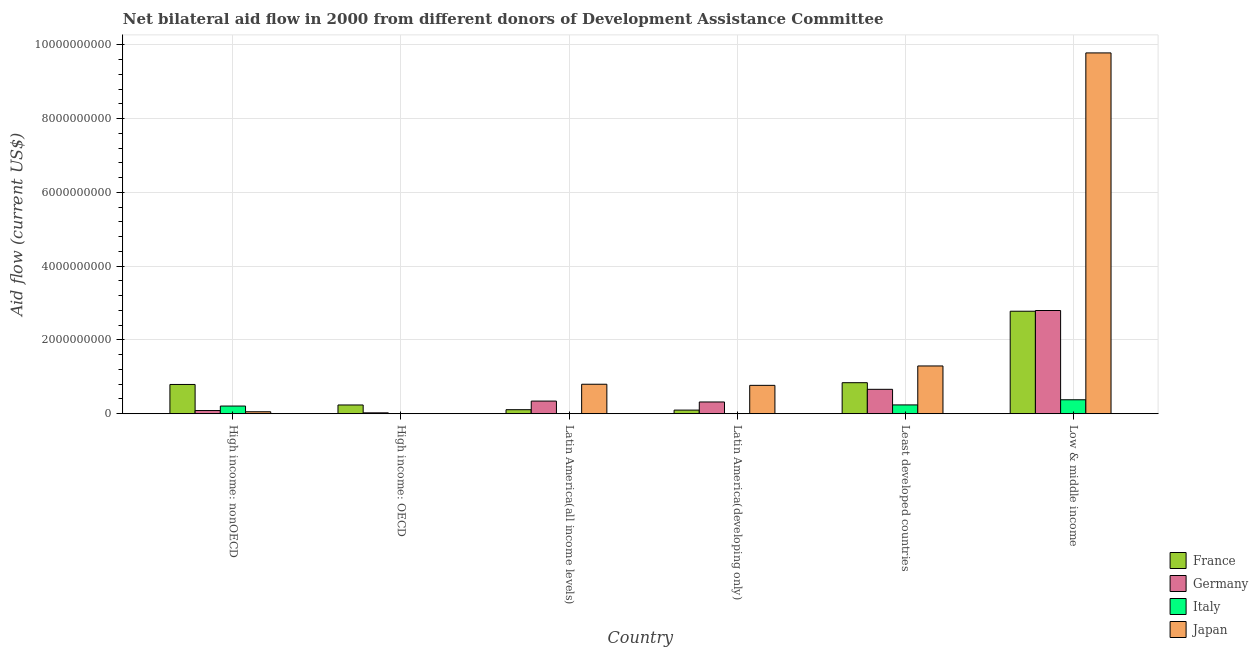How many groups of bars are there?
Your response must be concise. 6. How many bars are there on the 1st tick from the left?
Make the answer very short. 4. What is the label of the 1st group of bars from the left?
Make the answer very short. High income: nonOECD. What is the amount of aid given by france in Latin America(developing only)?
Your answer should be very brief. 9.84e+07. Across all countries, what is the maximum amount of aid given by italy?
Ensure brevity in your answer.  3.79e+08. What is the total amount of aid given by italy in the graph?
Give a very brief answer. 8.29e+08. What is the difference between the amount of aid given by france in High income: nonOECD and that in Least developed countries?
Offer a very short reply. -4.81e+07. What is the difference between the amount of aid given by japan in Latin America(all income levels) and the amount of aid given by italy in Low & middle income?
Your response must be concise. 4.21e+08. What is the average amount of aid given by germany per country?
Your response must be concise. 7.06e+08. What is the difference between the amount of aid given by japan and amount of aid given by france in High income: nonOECD?
Provide a short and direct response. -7.40e+08. In how many countries, is the amount of aid given by france greater than 6800000000 US$?
Offer a terse response. 0. What is the ratio of the amount of aid given by germany in High income: OECD to that in High income: nonOECD?
Provide a succinct answer. 0.28. Is the difference between the amount of aid given by italy in High income: nonOECD and Low & middle income greater than the difference between the amount of aid given by france in High income: nonOECD and Low & middle income?
Give a very brief answer. Yes. What is the difference between the highest and the second highest amount of aid given by germany?
Ensure brevity in your answer.  2.14e+09. What is the difference between the highest and the lowest amount of aid given by japan?
Your answer should be very brief. 9.78e+09. In how many countries, is the amount of aid given by france greater than the average amount of aid given by france taken over all countries?
Provide a short and direct response. 2. Is it the case that in every country, the sum of the amount of aid given by japan and amount of aid given by germany is greater than the sum of amount of aid given by italy and amount of aid given by france?
Give a very brief answer. No. Is it the case that in every country, the sum of the amount of aid given by france and amount of aid given by germany is greater than the amount of aid given by italy?
Ensure brevity in your answer.  Yes. How many bars are there?
Provide a short and direct response. 21. Are all the bars in the graph horizontal?
Offer a very short reply. No. What is the difference between two consecutive major ticks on the Y-axis?
Your response must be concise. 2.00e+09. Does the graph contain any zero values?
Provide a short and direct response. Yes. How are the legend labels stacked?
Offer a very short reply. Vertical. What is the title of the graph?
Your answer should be compact. Net bilateral aid flow in 2000 from different donors of Development Assistance Committee. What is the label or title of the X-axis?
Your response must be concise. Country. What is the Aid flow (current US$) of France in High income: nonOECD?
Make the answer very short. 7.94e+08. What is the Aid flow (current US$) of Germany in High income: nonOECD?
Your answer should be compact. 8.66e+07. What is the Aid flow (current US$) of Italy in High income: nonOECD?
Offer a terse response. 2.08e+08. What is the Aid flow (current US$) of Japan in High income: nonOECD?
Give a very brief answer. 5.39e+07. What is the Aid flow (current US$) in France in High income: OECD?
Your answer should be very brief. 2.37e+08. What is the Aid flow (current US$) of Germany in High income: OECD?
Make the answer very short. 2.45e+07. What is the Aid flow (current US$) in Italy in High income: OECD?
Keep it short and to the point. 2.94e+06. What is the Aid flow (current US$) of France in Latin America(all income levels)?
Your response must be concise. 1.09e+08. What is the Aid flow (current US$) of Germany in Latin America(all income levels)?
Make the answer very short. 3.43e+08. What is the Aid flow (current US$) in Italy in Latin America(all income levels)?
Offer a very short reply. 0. What is the Aid flow (current US$) of Japan in Latin America(all income levels)?
Give a very brief answer. 8.00e+08. What is the Aid flow (current US$) of France in Latin America(developing only)?
Your answer should be compact. 9.84e+07. What is the Aid flow (current US$) of Germany in Latin America(developing only)?
Your response must be concise. 3.19e+08. What is the Aid flow (current US$) in Italy in Latin America(developing only)?
Offer a terse response. 0. What is the Aid flow (current US$) in Japan in Latin America(developing only)?
Provide a succinct answer. 7.69e+08. What is the Aid flow (current US$) of France in Least developed countries?
Your response must be concise. 8.42e+08. What is the Aid flow (current US$) in Germany in Least developed countries?
Your response must be concise. 6.62e+08. What is the Aid flow (current US$) in Italy in Least developed countries?
Give a very brief answer. 2.39e+08. What is the Aid flow (current US$) in Japan in Least developed countries?
Your answer should be compact. 1.30e+09. What is the Aid flow (current US$) of France in Low & middle income?
Give a very brief answer. 2.78e+09. What is the Aid flow (current US$) of Germany in Low & middle income?
Offer a terse response. 2.80e+09. What is the Aid flow (current US$) in Italy in Low & middle income?
Ensure brevity in your answer.  3.79e+08. What is the Aid flow (current US$) in Japan in Low & middle income?
Provide a short and direct response. 9.78e+09. Across all countries, what is the maximum Aid flow (current US$) in France?
Ensure brevity in your answer.  2.78e+09. Across all countries, what is the maximum Aid flow (current US$) in Germany?
Ensure brevity in your answer.  2.80e+09. Across all countries, what is the maximum Aid flow (current US$) in Italy?
Your answer should be very brief. 3.79e+08. Across all countries, what is the maximum Aid flow (current US$) of Japan?
Offer a terse response. 9.78e+09. Across all countries, what is the minimum Aid flow (current US$) in France?
Make the answer very short. 9.84e+07. Across all countries, what is the minimum Aid flow (current US$) in Germany?
Ensure brevity in your answer.  2.45e+07. Across all countries, what is the minimum Aid flow (current US$) of Italy?
Keep it short and to the point. 0. Across all countries, what is the minimum Aid flow (current US$) of Japan?
Offer a terse response. 0. What is the total Aid flow (current US$) in France in the graph?
Your response must be concise. 4.86e+09. What is the total Aid flow (current US$) of Germany in the graph?
Give a very brief answer. 4.23e+09. What is the total Aid flow (current US$) of Italy in the graph?
Your response must be concise. 8.29e+08. What is the total Aid flow (current US$) of Japan in the graph?
Provide a succinct answer. 1.27e+1. What is the difference between the Aid flow (current US$) in France in High income: nonOECD and that in High income: OECD?
Provide a short and direct response. 5.56e+08. What is the difference between the Aid flow (current US$) of Germany in High income: nonOECD and that in High income: OECD?
Offer a terse response. 6.21e+07. What is the difference between the Aid flow (current US$) of Italy in High income: nonOECD and that in High income: OECD?
Offer a very short reply. 2.05e+08. What is the difference between the Aid flow (current US$) in France in High income: nonOECD and that in Latin America(all income levels)?
Provide a succinct answer. 6.84e+08. What is the difference between the Aid flow (current US$) in Germany in High income: nonOECD and that in Latin America(all income levels)?
Your answer should be compact. -2.56e+08. What is the difference between the Aid flow (current US$) in Japan in High income: nonOECD and that in Latin America(all income levels)?
Provide a short and direct response. -7.46e+08. What is the difference between the Aid flow (current US$) in France in High income: nonOECD and that in Latin America(developing only)?
Ensure brevity in your answer.  6.95e+08. What is the difference between the Aid flow (current US$) in Germany in High income: nonOECD and that in Latin America(developing only)?
Offer a very short reply. -2.32e+08. What is the difference between the Aid flow (current US$) of Japan in High income: nonOECD and that in Latin America(developing only)?
Your response must be concise. -7.16e+08. What is the difference between the Aid flow (current US$) of France in High income: nonOECD and that in Least developed countries?
Your response must be concise. -4.81e+07. What is the difference between the Aid flow (current US$) in Germany in High income: nonOECD and that in Least developed countries?
Make the answer very short. -5.75e+08. What is the difference between the Aid flow (current US$) in Italy in High income: nonOECD and that in Least developed countries?
Provide a succinct answer. -3.09e+07. What is the difference between the Aid flow (current US$) of Japan in High income: nonOECD and that in Least developed countries?
Make the answer very short. -1.24e+09. What is the difference between the Aid flow (current US$) in France in High income: nonOECD and that in Low & middle income?
Your answer should be very brief. -1.99e+09. What is the difference between the Aid flow (current US$) in Germany in High income: nonOECD and that in Low & middle income?
Offer a terse response. -2.71e+09. What is the difference between the Aid flow (current US$) of Italy in High income: nonOECD and that in Low & middle income?
Keep it short and to the point. -1.70e+08. What is the difference between the Aid flow (current US$) in Japan in High income: nonOECD and that in Low & middle income?
Your response must be concise. -9.73e+09. What is the difference between the Aid flow (current US$) in France in High income: OECD and that in Latin America(all income levels)?
Your response must be concise. 1.28e+08. What is the difference between the Aid flow (current US$) in Germany in High income: OECD and that in Latin America(all income levels)?
Offer a very short reply. -3.18e+08. What is the difference between the Aid flow (current US$) in France in High income: OECD and that in Latin America(developing only)?
Your answer should be very brief. 1.39e+08. What is the difference between the Aid flow (current US$) in Germany in High income: OECD and that in Latin America(developing only)?
Ensure brevity in your answer.  -2.94e+08. What is the difference between the Aid flow (current US$) in France in High income: OECD and that in Least developed countries?
Give a very brief answer. -6.04e+08. What is the difference between the Aid flow (current US$) in Germany in High income: OECD and that in Least developed countries?
Make the answer very short. -6.37e+08. What is the difference between the Aid flow (current US$) of Italy in High income: OECD and that in Least developed countries?
Keep it short and to the point. -2.36e+08. What is the difference between the Aid flow (current US$) in France in High income: OECD and that in Low & middle income?
Ensure brevity in your answer.  -2.54e+09. What is the difference between the Aid flow (current US$) of Germany in High income: OECD and that in Low & middle income?
Offer a terse response. -2.77e+09. What is the difference between the Aid flow (current US$) of Italy in High income: OECD and that in Low & middle income?
Provide a short and direct response. -3.76e+08. What is the difference between the Aid flow (current US$) in France in Latin America(all income levels) and that in Latin America(developing only)?
Offer a very short reply. 1.10e+07. What is the difference between the Aid flow (current US$) in Germany in Latin America(all income levels) and that in Latin America(developing only)?
Make the answer very short. 2.43e+07. What is the difference between the Aid flow (current US$) in Japan in Latin America(all income levels) and that in Latin America(developing only)?
Ensure brevity in your answer.  3.01e+07. What is the difference between the Aid flow (current US$) in France in Latin America(all income levels) and that in Least developed countries?
Provide a short and direct response. -7.32e+08. What is the difference between the Aid flow (current US$) in Germany in Latin America(all income levels) and that in Least developed countries?
Make the answer very short. -3.19e+08. What is the difference between the Aid flow (current US$) of Japan in Latin America(all income levels) and that in Least developed countries?
Your response must be concise. -4.96e+08. What is the difference between the Aid flow (current US$) of France in Latin America(all income levels) and that in Low & middle income?
Your answer should be compact. -2.67e+09. What is the difference between the Aid flow (current US$) of Germany in Latin America(all income levels) and that in Low & middle income?
Provide a short and direct response. -2.46e+09. What is the difference between the Aid flow (current US$) in Japan in Latin America(all income levels) and that in Low & middle income?
Make the answer very short. -8.98e+09. What is the difference between the Aid flow (current US$) in France in Latin America(developing only) and that in Least developed countries?
Offer a very short reply. -7.43e+08. What is the difference between the Aid flow (current US$) of Germany in Latin America(developing only) and that in Least developed countries?
Your response must be concise. -3.43e+08. What is the difference between the Aid flow (current US$) in Japan in Latin America(developing only) and that in Least developed countries?
Ensure brevity in your answer.  -5.26e+08. What is the difference between the Aid flow (current US$) in France in Latin America(developing only) and that in Low & middle income?
Give a very brief answer. -2.68e+09. What is the difference between the Aid flow (current US$) of Germany in Latin America(developing only) and that in Low & middle income?
Give a very brief answer. -2.48e+09. What is the difference between the Aid flow (current US$) of Japan in Latin America(developing only) and that in Low & middle income?
Ensure brevity in your answer.  -9.01e+09. What is the difference between the Aid flow (current US$) of France in Least developed countries and that in Low & middle income?
Offer a terse response. -1.94e+09. What is the difference between the Aid flow (current US$) of Germany in Least developed countries and that in Low & middle income?
Provide a succinct answer. -2.14e+09. What is the difference between the Aid flow (current US$) of Italy in Least developed countries and that in Low & middle income?
Give a very brief answer. -1.39e+08. What is the difference between the Aid flow (current US$) in Japan in Least developed countries and that in Low & middle income?
Give a very brief answer. -8.49e+09. What is the difference between the Aid flow (current US$) in France in High income: nonOECD and the Aid flow (current US$) in Germany in High income: OECD?
Ensure brevity in your answer.  7.69e+08. What is the difference between the Aid flow (current US$) of France in High income: nonOECD and the Aid flow (current US$) of Italy in High income: OECD?
Offer a terse response. 7.91e+08. What is the difference between the Aid flow (current US$) of Germany in High income: nonOECD and the Aid flow (current US$) of Italy in High income: OECD?
Keep it short and to the point. 8.37e+07. What is the difference between the Aid flow (current US$) in France in High income: nonOECD and the Aid flow (current US$) in Germany in Latin America(all income levels)?
Provide a succinct answer. 4.51e+08. What is the difference between the Aid flow (current US$) in France in High income: nonOECD and the Aid flow (current US$) in Japan in Latin America(all income levels)?
Ensure brevity in your answer.  -6.02e+06. What is the difference between the Aid flow (current US$) of Germany in High income: nonOECD and the Aid flow (current US$) of Japan in Latin America(all income levels)?
Your response must be concise. -7.13e+08. What is the difference between the Aid flow (current US$) of Italy in High income: nonOECD and the Aid flow (current US$) of Japan in Latin America(all income levels)?
Provide a short and direct response. -5.91e+08. What is the difference between the Aid flow (current US$) of France in High income: nonOECD and the Aid flow (current US$) of Germany in Latin America(developing only)?
Your answer should be very brief. 4.75e+08. What is the difference between the Aid flow (current US$) in France in High income: nonOECD and the Aid flow (current US$) in Japan in Latin America(developing only)?
Your answer should be compact. 2.41e+07. What is the difference between the Aid flow (current US$) of Germany in High income: nonOECD and the Aid flow (current US$) of Japan in Latin America(developing only)?
Provide a short and direct response. -6.83e+08. What is the difference between the Aid flow (current US$) of Italy in High income: nonOECD and the Aid flow (current US$) of Japan in Latin America(developing only)?
Provide a succinct answer. -5.61e+08. What is the difference between the Aid flow (current US$) in France in High income: nonOECD and the Aid flow (current US$) in Germany in Least developed countries?
Keep it short and to the point. 1.32e+08. What is the difference between the Aid flow (current US$) in France in High income: nonOECD and the Aid flow (current US$) in Italy in Least developed countries?
Offer a very short reply. 5.54e+08. What is the difference between the Aid flow (current US$) in France in High income: nonOECD and the Aid flow (current US$) in Japan in Least developed countries?
Your answer should be very brief. -5.02e+08. What is the difference between the Aid flow (current US$) of Germany in High income: nonOECD and the Aid flow (current US$) of Italy in Least developed countries?
Offer a very short reply. -1.53e+08. What is the difference between the Aid flow (current US$) in Germany in High income: nonOECD and the Aid flow (current US$) in Japan in Least developed countries?
Offer a terse response. -1.21e+09. What is the difference between the Aid flow (current US$) of Italy in High income: nonOECD and the Aid flow (current US$) of Japan in Least developed countries?
Provide a short and direct response. -1.09e+09. What is the difference between the Aid flow (current US$) in France in High income: nonOECD and the Aid flow (current US$) in Germany in Low & middle income?
Make the answer very short. -2.00e+09. What is the difference between the Aid flow (current US$) in France in High income: nonOECD and the Aid flow (current US$) in Italy in Low & middle income?
Ensure brevity in your answer.  4.15e+08. What is the difference between the Aid flow (current US$) of France in High income: nonOECD and the Aid flow (current US$) of Japan in Low & middle income?
Provide a short and direct response. -8.99e+09. What is the difference between the Aid flow (current US$) of Germany in High income: nonOECD and the Aid flow (current US$) of Italy in Low & middle income?
Your answer should be very brief. -2.92e+08. What is the difference between the Aid flow (current US$) in Germany in High income: nonOECD and the Aid flow (current US$) in Japan in Low & middle income?
Provide a succinct answer. -9.69e+09. What is the difference between the Aid flow (current US$) of Italy in High income: nonOECD and the Aid flow (current US$) of Japan in Low & middle income?
Keep it short and to the point. -9.57e+09. What is the difference between the Aid flow (current US$) in France in High income: OECD and the Aid flow (current US$) in Germany in Latin America(all income levels)?
Offer a very short reply. -1.06e+08. What is the difference between the Aid flow (current US$) of France in High income: OECD and the Aid flow (current US$) of Japan in Latin America(all income levels)?
Provide a short and direct response. -5.62e+08. What is the difference between the Aid flow (current US$) of Germany in High income: OECD and the Aid flow (current US$) of Japan in Latin America(all income levels)?
Your response must be concise. -7.75e+08. What is the difference between the Aid flow (current US$) in Italy in High income: OECD and the Aid flow (current US$) in Japan in Latin America(all income levels)?
Your response must be concise. -7.97e+08. What is the difference between the Aid flow (current US$) of France in High income: OECD and the Aid flow (current US$) of Germany in Latin America(developing only)?
Provide a short and direct response. -8.14e+07. What is the difference between the Aid flow (current US$) in France in High income: OECD and the Aid flow (current US$) in Japan in Latin America(developing only)?
Offer a very short reply. -5.32e+08. What is the difference between the Aid flow (current US$) in Germany in High income: OECD and the Aid flow (current US$) in Japan in Latin America(developing only)?
Keep it short and to the point. -7.45e+08. What is the difference between the Aid flow (current US$) of Italy in High income: OECD and the Aid flow (current US$) of Japan in Latin America(developing only)?
Provide a short and direct response. -7.67e+08. What is the difference between the Aid flow (current US$) in France in High income: OECD and the Aid flow (current US$) in Germany in Least developed countries?
Provide a succinct answer. -4.25e+08. What is the difference between the Aid flow (current US$) of France in High income: OECD and the Aid flow (current US$) of Italy in Least developed countries?
Make the answer very short. -1.90e+06. What is the difference between the Aid flow (current US$) in France in High income: OECD and the Aid flow (current US$) in Japan in Least developed countries?
Provide a succinct answer. -1.06e+09. What is the difference between the Aid flow (current US$) of Germany in High income: OECD and the Aid flow (current US$) of Italy in Least developed countries?
Make the answer very short. -2.15e+08. What is the difference between the Aid flow (current US$) in Germany in High income: OECD and the Aid flow (current US$) in Japan in Least developed countries?
Provide a succinct answer. -1.27e+09. What is the difference between the Aid flow (current US$) of Italy in High income: OECD and the Aid flow (current US$) of Japan in Least developed countries?
Offer a very short reply. -1.29e+09. What is the difference between the Aid flow (current US$) in France in High income: OECD and the Aid flow (current US$) in Germany in Low & middle income?
Your answer should be very brief. -2.56e+09. What is the difference between the Aid flow (current US$) of France in High income: OECD and the Aid flow (current US$) of Italy in Low & middle income?
Your response must be concise. -1.41e+08. What is the difference between the Aid flow (current US$) in France in High income: OECD and the Aid flow (current US$) in Japan in Low & middle income?
Your answer should be very brief. -9.54e+09. What is the difference between the Aid flow (current US$) in Germany in High income: OECD and the Aid flow (current US$) in Italy in Low & middle income?
Provide a short and direct response. -3.54e+08. What is the difference between the Aid flow (current US$) of Germany in High income: OECD and the Aid flow (current US$) of Japan in Low & middle income?
Offer a very short reply. -9.76e+09. What is the difference between the Aid flow (current US$) of Italy in High income: OECD and the Aid flow (current US$) of Japan in Low & middle income?
Your response must be concise. -9.78e+09. What is the difference between the Aid flow (current US$) of France in Latin America(all income levels) and the Aid flow (current US$) of Germany in Latin America(developing only)?
Your answer should be compact. -2.09e+08. What is the difference between the Aid flow (current US$) of France in Latin America(all income levels) and the Aid flow (current US$) of Japan in Latin America(developing only)?
Provide a short and direct response. -6.60e+08. What is the difference between the Aid flow (current US$) in Germany in Latin America(all income levels) and the Aid flow (current US$) in Japan in Latin America(developing only)?
Give a very brief answer. -4.27e+08. What is the difference between the Aid flow (current US$) in France in Latin America(all income levels) and the Aid flow (current US$) in Germany in Least developed countries?
Give a very brief answer. -5.52e+08. What is the difference between the Aid flow (current US$) of France in Latin America(all income levels) and the Aid flow (current US$) of Italy in Least developed countries?
Make the answer very short. -1.30e+08. What is the difference between the Aid flow (current US$) of France in Latin America(all income levels) and the Aid flow (current US$) of Japan in Least developed countries?
Give a very brief answer. -1.19e+09. What is the difference between the Aid flow (current US$) of Germany in Latin America(all income levels) and the Aid flow (current US$) of Italy in Least developed countries?
Make the answer very short. 1.04e+08. What is the difference between the Aid flow (current US$) in Germany in Latin America(all income levels) and the Aid flow (current US$) in Japan in Least developed countries?
Give a very brief answer. -9.52e+08. What is the difference between the Aid flow (current US$) of France in Latin America(all income levels) and the Aid flow (current US$) of Germany in Low & middle income?
Your answer should be very brief. -2.69e+09. What is the difference between the Aid flow (current US$) in France in Latin America(all income levels) and the Aid flow (current US$) in Italy in Low & middle income?
Offer a very short reply. -2.69e+08. What is the difference between the Aid flow (current US$) of France in Latin America(all income levels) and the Aid flow (current US$) of Japan in Low & middle income?
Ensure brevity in your answer.  -9.67e+09. What is the difference between the Aid flow (current US$) of Germany in Latin America(all income levels) and the Aid flow (current US$) of Italy in Low & middle income?
Your response must be concise. -3.58e+07. What is the difference between the Aid flow (current US$) of Germany in Latin America(all income levels) and the Aid flow (current US$) of Japan in Low & middle income?
Offer a terse response. -9.44e+09. What is the difference between the Aid flow (current US$) in France in Latin America(developing only) and the Aid flow (current US$) in Germany in Least developed countries?
Offer a terse response. -5.64e+08. What is the difference between the Aid flow (current US$) in France in Latin America(developing only) and the Aid flow (current US$) in Italy in Least developed countries?
Offer a terse response. -1.41e+08. What is the difference between the Aid flow (current US$) of France in Latin America(developing only) and the Aid flow (current US$) of Japan in Least developed countries?
Offer a very short reply. -1.20e+09. What is the difference between the Aid flow (current US$) of Germany in Latin America(developing only) and the Aid flow (current US$) of Italy in Least developed countries?
Keep it short and to the point. 7.95e+07. What is the difference between the Aid flow (current US$) of Germany in Latin America(developing only) and the Aid flow (current US$) of Japan in Least developed countries?
Offer a very short reply. -9.76e+08. What is the difference between the Aid flow (current US$) in France in Latin America(developing only) and the Aid flow (current US$) in Germany in Low & middle income?
Keep it short and to the point. -2.70e+09. What is the difference between the Aid flow (current US$) of France in Latin America(developing only) and the Aid flow (current US$) of Italy in Low & middle income?
Offer a very short reply. -2.80e+08. What is the difference between the Aid flow (current US$) in France in Latin America(developing only) and the Aid flow (current US$) in Japan in Low & middle income?
Ensure brevity in your answer.  -9.68e+09. What is the difference between the Aid flow (current US$) of Germany in Latin America(developing only) and the Aid flow (current US$) of Italy in Low & middle income?
Your answer should be compact. -6.00e+07. What is the difference between the Aid flow (current US$) in Germany in Latin America(developing only) and the Aid flow (current US$) in Japan in Low & middle income?
Your response must be concise. -9.46e+09. What is the difference between the Aid flow (current US$) in France in Least developed countries and the Aid flow (current US$) in Germany in Low & middle income?
Offer a very short reply. -1.96e+09. What is the difference between the Aid flow (current US$) in France in Least developed countries and the Aid flow (current US$) in Italy in Low & middle income?
Your answer should be very brief. 4.63e+08. What is the difference between the Aid flow (current US$) of France in Least developed countries and the Aid flow (current US$) of Japan in Low & middle income?
Provide a short and direct response. -8.94e+09. What is the difference between the Aid flow (current US$) of Germany in Least developed countries and the Aid flow (current US$) of Italy in Low & middle income?
Keep it short and to the point. 2.83e+08. What is the difference between the Aid flow (current US$) in Germany in Least developed countries and the Aid flow (current US$) in Japan in Low & middle income?
Offer a terse response. -9.12e+09. What is the difference between the Aid flow (current US$) of Italy in Least developed countries and the Aid flow (current US$) of Japan in Low & middle income?
Give a very brief answer. -9.54e+09. What is the average Aid flow (current US$) in France per country?
Provide a succinct answer. 8.10e+08. What is the average Aid flow (current US$) in Germany per country?
Make the answer very short. 7.06e+08. What is the average Aid flow (current US$) in Italy per country?
Ensure brevity in your answer.  1.38e+08. What is the average Aid flow (current US$) of Japan per country?
Ensure brevity in your answer.  2.12e+09. What is the difference between the Aid flow (current US$) in France and Aid flow (current US$) in Germany in High income: nonOECD?
Provide a short and direct response. 7.07e+08. What is the difference between the Aid flow (current US$) in France and Aid flow (current US$) in Italy in High income: nonOECD?
Provide a short and direct response. 5.85e+08. What is the difference between the Aid flow (current US$) in France and Aid flow (current US$) in Japan in High income: nonOECD?
Offer a terse response. 7.40e+08. What is the difference between the Aid flow (current US$) of Germany and Aid flow (current US$) of Italy in High income: nonOECD?
Your response must be concise. -1.22e+08. What is the difference between the Aid flow (current US$) of Germany and Aid flow (current US$) of Japan in High income: nonOECD?
Make the answer very short. 3.27e+07. What is the difference between the Aid flow (current US$) of Italy and Aid flow (current US$) of Japan in High income: nonOECD?
Offer a very short reply. 1.54e+08. What is the difference between the Aid flow (current US$) of France and Aid flow (current US$) of Germany in High income: OECD?
Keep it short and to the point. 2.13e+08. What is the difference between the Aid flow (current US$) of France and Aid flow (current US$) of Italy in High income: OECD?
Make the answer very short. 2.34e+08. What is the difference between the Aid flow (current US$) in Germany and Aid flow (current US$) in Italy in High income: OECD?
Give a very brief answer. 2.16e+07. What is the difference between the Aid flow (current US$) in France and Aid flow (current US$) in Germany in Latin America(all income levels)?
Make the answer very short. -2.33e+08. What is the difference between the Aid flow (current US$) of France and Aid flow (current US$) of Japan in Latin America(all income levels)?
Offer a very short reply. -6.90e+08. What is the difference between the Aid flow (current US$) of Germany and Aid flow (current US$) of Japan in Latin America(all income levels)?
Offer a very short reply. -4.57e+08. What is the difference between the Aid flow (current US$) in France and Aid flow (current US$) in Germany in Latin America(developing only)?
Make the answer very short. -2.20e+08. What is the difference between the Aid flow (current US$) of France and Aid flow (current US$) of Japan in Latin America(developing only)?
Ensure brevity in your answer.  -6.71e+08. What is the difference between the Aid flow (current US$) of Germany and Aid flow (current US$) of Japan in Latin America(developing only)?
Provide a succinct answer. -4.51e+08. What is the difference between the Aid flow (current US$) in France and Aid flow (current US$) in Germany in Least developed countries?
Keep it short and to the point. 1.80e+08. What is the difference between the Aid flow (current US$) of France and Aid flow (current US$) of Italy in Least developed countries?
Offer a very short reply. 6.02e+08. What is the difference between the Aid flow (current US$) of France and Aid flow (current US$) of Japan in Least developed countries?
Make the answer very short. -4.54e+08. What is the difference between the Aid flow (current US$) in Germany and Aid flow (current US$) in Italy in Least developed countries?
Ensure brevity in your answer.  4.23e+08. What is the difference between the Aid flow (current US$) of Germany and Aid flow (current US$) of Japan in Least developed countries?
Offer a very short reply. -6.33e+08. What is the difference between the Aid flow (current US$) of Italy and Aid flow (current US$) of Japan in Least developed countries?
Your answer should be compact. -1.06e+09. What is the difference between the Aid flow (current US$) in France and Aid flow (current US$) in Germany in Low & middle income?
Offer a terse response. -1.94e+07. What is the difference between the Aid flow (current US$) of France and Aid flow (current US$) of Italy in Low & middle income?
Provide a succinct answer. 2.40e+09. What is the difference between the Aid flow (current US$) of France and Aid flow (current US$) of Japan in Low & middle income?
Provide a short and direct response. -7.00e+09. What is the difference between the Aid flow (current US$) in Germany and Aid flow (current US$) in Italy in Low & middle income?
Provide a succinct answer. 2.42e+09. What is the difference between the Aid flow (current US$) of Germany and Aid flow (current US$) of Japan in Low & middle income?
Offer a very short reply. -6.98e+09. What is the difference between the Aid flow (current US$) in Italy and Aid flow (current US$) in Japan in Low & middle income?
Ensure brevity in your answer.  -9.40e+09. What is the ratio of the Aid flow (current US$) of France in High income: nonOECD to that in High income: OECD?
Your answer should be compact. 3.34. What is the ratio of the Aid flow (current US$) of Germany in High income: nonOECD to that in High income: OECD?
Offer a very short reply. 3.54. What is the ratio of the Aid flow (current US$) in Italy in High income: nonOECD to that in High income: OECD?
Provide a short and direct response. 70.85. What is the ratio of the Aid flow (current US$) of France in High income: nonOECD to that in Latin America(all income levels)?
Ensure brevity in your answer.  7.25. What is the ratio of the Aid flow (current US$) of Germany in High income: nonOECD to that in Latin America(all income levels)?
Your response must be concise. 0.25. What is the ratio of the Aid flow (current US$) in Japan in High income: nonOECD to that in Latin America(all income levels)?
Provide a succinct answer. 0.07. What is the ratio of the Aid flow (current US$) of France in High income: nonOECD to that in Latin America(developing only)?
Your response must be concise. 8.06. What is the ratio of the Aid flow (current US$) of Germany in High income: nonOECD to that in Latin America(developing only)?
Make the answer very short. 0.27. What is the ratio of the Aid flow (current US$) in Japan in High income: nonOECD to that in Latin America(developing only)?
Keep it short and to the point. 0.07. What is the ratio of the Aid flow (current US$) of France in High income: nonOECD to that in Least developed countries?
Give a very brief answer. 0.94. What is the ratio of the Aid flow (current US$) in Germany in High income: nonOECD to that in Least developed countries?
Provide a short and direct response. 0.13. What is the ratio of the Aid flow (current US$) of Italy in High income: nonOECD to that in Least developed countries?
Your answer should be compact. 0.87. What is the ratio of the Aid flow (current US$) of Japan in High income: nonOECD to that in Least developed countries?
Keep it short and to the point. 0.04. What is the ratio of the Aid flow (current US$) of France in High income: nonOECD to that in Low & middle income?
Your answer should be very brief. 0.29. What is the ratio of the Aid flow (current US$) in Germany in High income: nonOECD to that in Low & middle income?
Your response must be concise. 0.03. What is the ratio of the Aid flow (current US$) in Italy in High income: nonOECD to that in Low & middle income?
Offer a very short reply. 0.55. What is the ratio of the Aid flow (current US$) of Japan in High income: nonOECD to that in Low & middle income?
Offer a very short reply. 0.01. What is the ratio of the Aid flow (current US$) of France in High income: OECD to that in Latin America(all income levels)?
Provide a short and direct response. 2.17. What is the ratio of the Aid flow (current US$) of Germany in High income: OECD to that in Latin America(all income levels)?
Keep it short and to the point. 0.07. What is the ratio of the Aid flow (current US$) in France in High income: OECD to that in Latin America(developing only)?
Offer a terse response. 2.41. What is the ratio of the Aid flow (current US$) in Germany in High income: OECD to that in Latin America(developing only)?
Ensure brevity in your answer.  0.08. What is the ratio of the Aid flow (current US$) of France in High income: OECD to that in Least developed countries?
Your response must be concise. 0.28. What is the ratio of the Aid flow (current US$) of Germany in High income: OECD to that in Least developed countries?
Ensure brevity in your answer.  0.04. What is the ratio of the Aid flow (current US$) of Italy in High income: OECD to that in Least developed countries?
Keep it short and to the point. 0.01. What is the ratio of the Aid flow (current US$) in France in High income: OECD to that in Low & middle income?
Provide a short and direct response. 0.09. What is the ratio of the Aid flow (current US$) of Germany in High income: OECD to that in Low & middle income?
Your answer should be very brief. 0.01. What is the ratio of the Aid flow (current US$) in Italy in High income: OECD to that in Low & middle income?
Your answer should be very brief. 0.01. What is the ratio of the Aid flow (current US$) in France in Latin America(all income levels) to that in Latin America(developing only)?
Ensure brevity in your answer.  1.11. What is the ratio of the Aid flow (current US$) of Germany in Latin America(all income levels) to that in Latin America(developing only)?
Provide a short and direct response. 1.08. What is the ratio of the Aid flow (current US$) in Japan in Latin America(all income levels) to that in Latin America(developing only)?
Ensure brevity in your answer.  1.04. What is the ratio of the Aid flow (current US$) of France in Latin America(all income levels) to that in Least developed countries?
Provide a short and direct response. 0.13. What is the ratio of the Aid flow (current US$) of Germany in Latin America(all income levels) to that in Least developed countries?
Offer a very short reply. 0.52. What is the ratio of the Aid flow (current US$) of Japan in Latin America(all income levels) to that in Least developed countries?
Provide a succinct answer. 0.62. What is the ratio of the Aid flow (current US$) of France in Latin America(all income levels) to that in Low & middle income?
Provide a succinct answer. 0.04. What is the ratio of the Aid flow (current US$) in Germany in Latin America(all income levels) to that in Low & middle income?
Your answer should be compact. 0.12. What is the ratio of the Aid flow (current US$) in Japan in Latin America(all income levels) to that in Low & middle income?
Offer a terse response. 0.08. What is the ratio of the Aid flow (current US$) of France in Latin America(developing only) to that in Least developed countries?
Provide a short and direct response. 0.12. What is the ratio of the Aid flow (current US$) of Germany in Latin America(developing only) to that in Least developed countries?
Keep it short and to the point. 0.48. What is the ratio of the Aid flow (current US$) of Japan in Latin America(developing only) to that in Least developed countries?
Make the answer very short. 0.59. What is the ratio of the Aid flow (current US$) of France in Latin America(developing only) to that in Low & middle income?
Offer a very short reply. 0.04. What is the ratio of the Aid flow (current US$) in Germany in Latin America(developing only) to that in Low & middle income?
Make the answer very short. 0.11. What is the ratio of the Aid flow (current US$) in Japan in Latin America(developing only) to that in Low & middle income?
Ensure brevity in your answer.  0.08. What is the ratio of the Aid flow (current US$) in France in Least developed countries to that in Low & middle income?
Give a very brief answer. 0.3. What is the ratio of the Aid flow (current US$) of Germany in Least developed countries to that in Low & middle income?
Keep it short and to the point. 0.24. What is the ratio of the Aid flow (current US$) of Italy in Least developed countries to that in Low & middle income?
Your answer should be compact. 0.63. What is the ratio of the Aid flow (current US$) in Japan in Least developed countries to that in Low & middle income?
Keep it short and to the point. 0.13. What is the difference between the highest and the second highest Aid flow (current US$) of France?
Give a very brief answer. 1.94e+09. What is the difference between the highest and the second highest Aid flow (current US$) in Germany?
Provide a short and direct response. 2.14e+09. What is the difference between the highest and the second highest Aid flow (current US$) of Italy?
Provide a short and direct response. 1.39e+08. What is the difference between the highest and the second highest Aid flow (current US$) in Japan?
Make the answer very short. 8.49e+09. What is the difference between the highest and the lowest Aid flow (current US$) of France?
Your response must be concise. 2.68e+09. What is the difference between the highest and the lowest Aid flow (current US$) of Germany?
Give a very brief answer. 2.77e+09. What is the difference between the highest and the lowest Aid flow (current US$) of Italy?
Make the answer very short. 3.79e+08. What is the difference between the highest and the lowest Aid flow (current US$) in Japan?
Offer a terse response. 9.78e+09. 